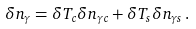Convert formula to latex. <formula><loc_0><loc_0><loc_500><loc_500>\delta n _ { \gamma } = \delta T _ { c } \delta n _ { \gamma c } + \delta T _ { s } \delta n _ { \gamma s } \, .</formula> 